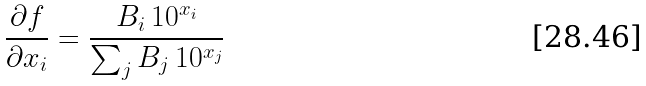Convert formula to latex. <formula><loc_0><loc_0><loc_500><loc_500>\frac { \partial f } { \partial x _ { i } } = \frac { B _ { i } \, 1 0 ^ { x _ { i } } } { \sum _ { j } B _ { j } \, 1 0 ^ { x _ { j } } }</formula> 